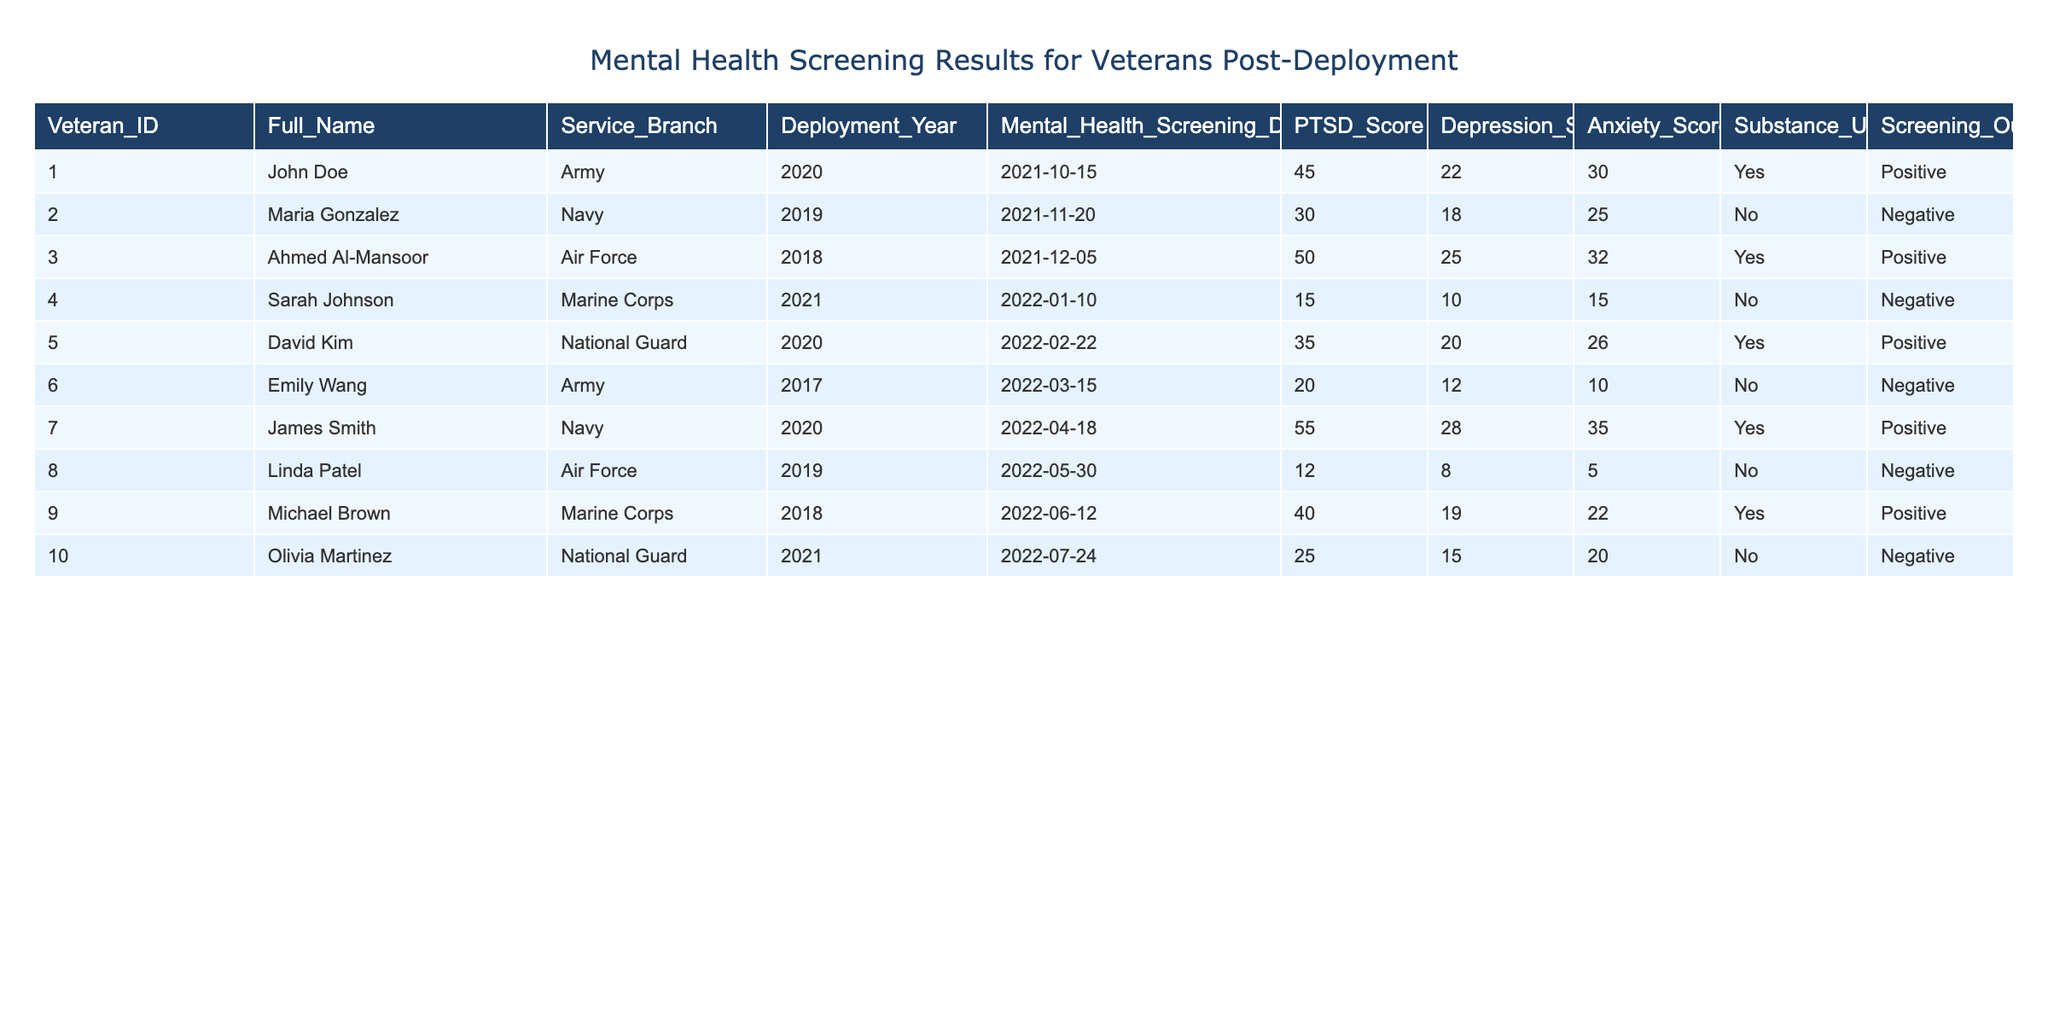What is the PTSD score of Ahmed Al-Mansoor? In the table, I locate Ahmed Al-Mansoor's row, which shows a PTSD score of 50.
Answer: 50 How many veterans screened positive for mental health issues? Looking at the screening outcome column, there are three rows where the screening outcome is marked as positive (John Doe, Ahmed Al-Mansoor, and James Smith).
Answer: 3 What is the average anxiety score of veterans who screened negative? I first identify the rows with negative screening outcomes (Sarah Johnson, Emily Wang, and Olivia Martinez) and sum their anxiety scores: 15 + 10 + 20 = 45. There are three such veterans, so I then find the average by dividing the total by 3, which equals 45 / 3 = 15.
Answer: 15 Is there a veteran who has both a high PTSD score and positive screening outcome? I look for veterans with high PTSD scores (greater than 40) and find John Doe (45) and Ahmed Al-Mansoor (50) both screening positive. Thus, the answer is yes.
Answer: Yes What is the difference between the highest and lowest depression scores among all veterans? The highest depression score is 28 (James Smith) and the lowest is 8 (Linda Patel). I calculate the difference as 28 - 8 = 20.
Answer: 20 How many veterans who scored above 40 on the PTSD scale also reported substance use? I review the PTSD scores and find two veterans, John Doe (score 45) and Ahmed Al-Mansoor (score 50), who reported substance use. The number of such veterans is 2.
Answer: 2 Does any veteran with a PTSD score below 20 have a positive screening outcome? Checking the table, the lowest PTSD score is 12 (Linda Patel) and she has a negative outcome. Hence, no veteran with a PTSD score below 20 has a positive screening outcome.
Answer: No What age group shows the highest average PTSD score, active duty, or National Guard veterans? I analyze the veterans from active duty branches (Army, Navy, Marine Corps, Air Force) and their PTSD scores (John Doe, Maria Gonzalez, Ahmed Al-Mansoor, Sarah Johnson, James Smith) sum to: 45 + 30 + 50 + 15 + 55 = 195 with 5 data points, yielding an average of 195 / 5 = 39. Since the National Guard veterans (David Kim and Olivia Martinez) have scores of 35 and 25, their average is (35 + 25) / 2 = 30. Therefore, active duty veterans have a higher average PTSD score.
Answer: Active Duty What is the significance of the deployment year in relation to mental health outcomes shown in the table? Analyzing the data, most veterans deployed in recent years (2020 and 2021) largely showed positive screening outcomes, indicating potential increased mental health risks linked to more recent deployments compared to those from earlier years (2017 or 2018 with no positives). Therefore, it suggests a trend in mental health impacts over time that could relate to deployment experiences.
Answer: Significant trends can be observed 